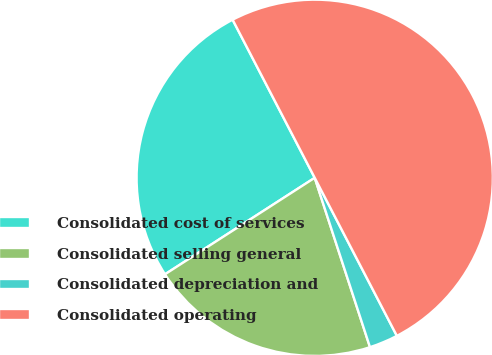Convert chart to OTSL. <chart><loc_0><loc_0><loc_500><loc_500><pie_chart><fcel>Consolidated cost of services<fcel>Consolidated selling general<fcel>Consolidated depreciation and<fcel>Consolidated operating<nl><fcel>26.49%<fcel>20.91%<fcel>2.61%<fcel>50.0%<nl></chart> 